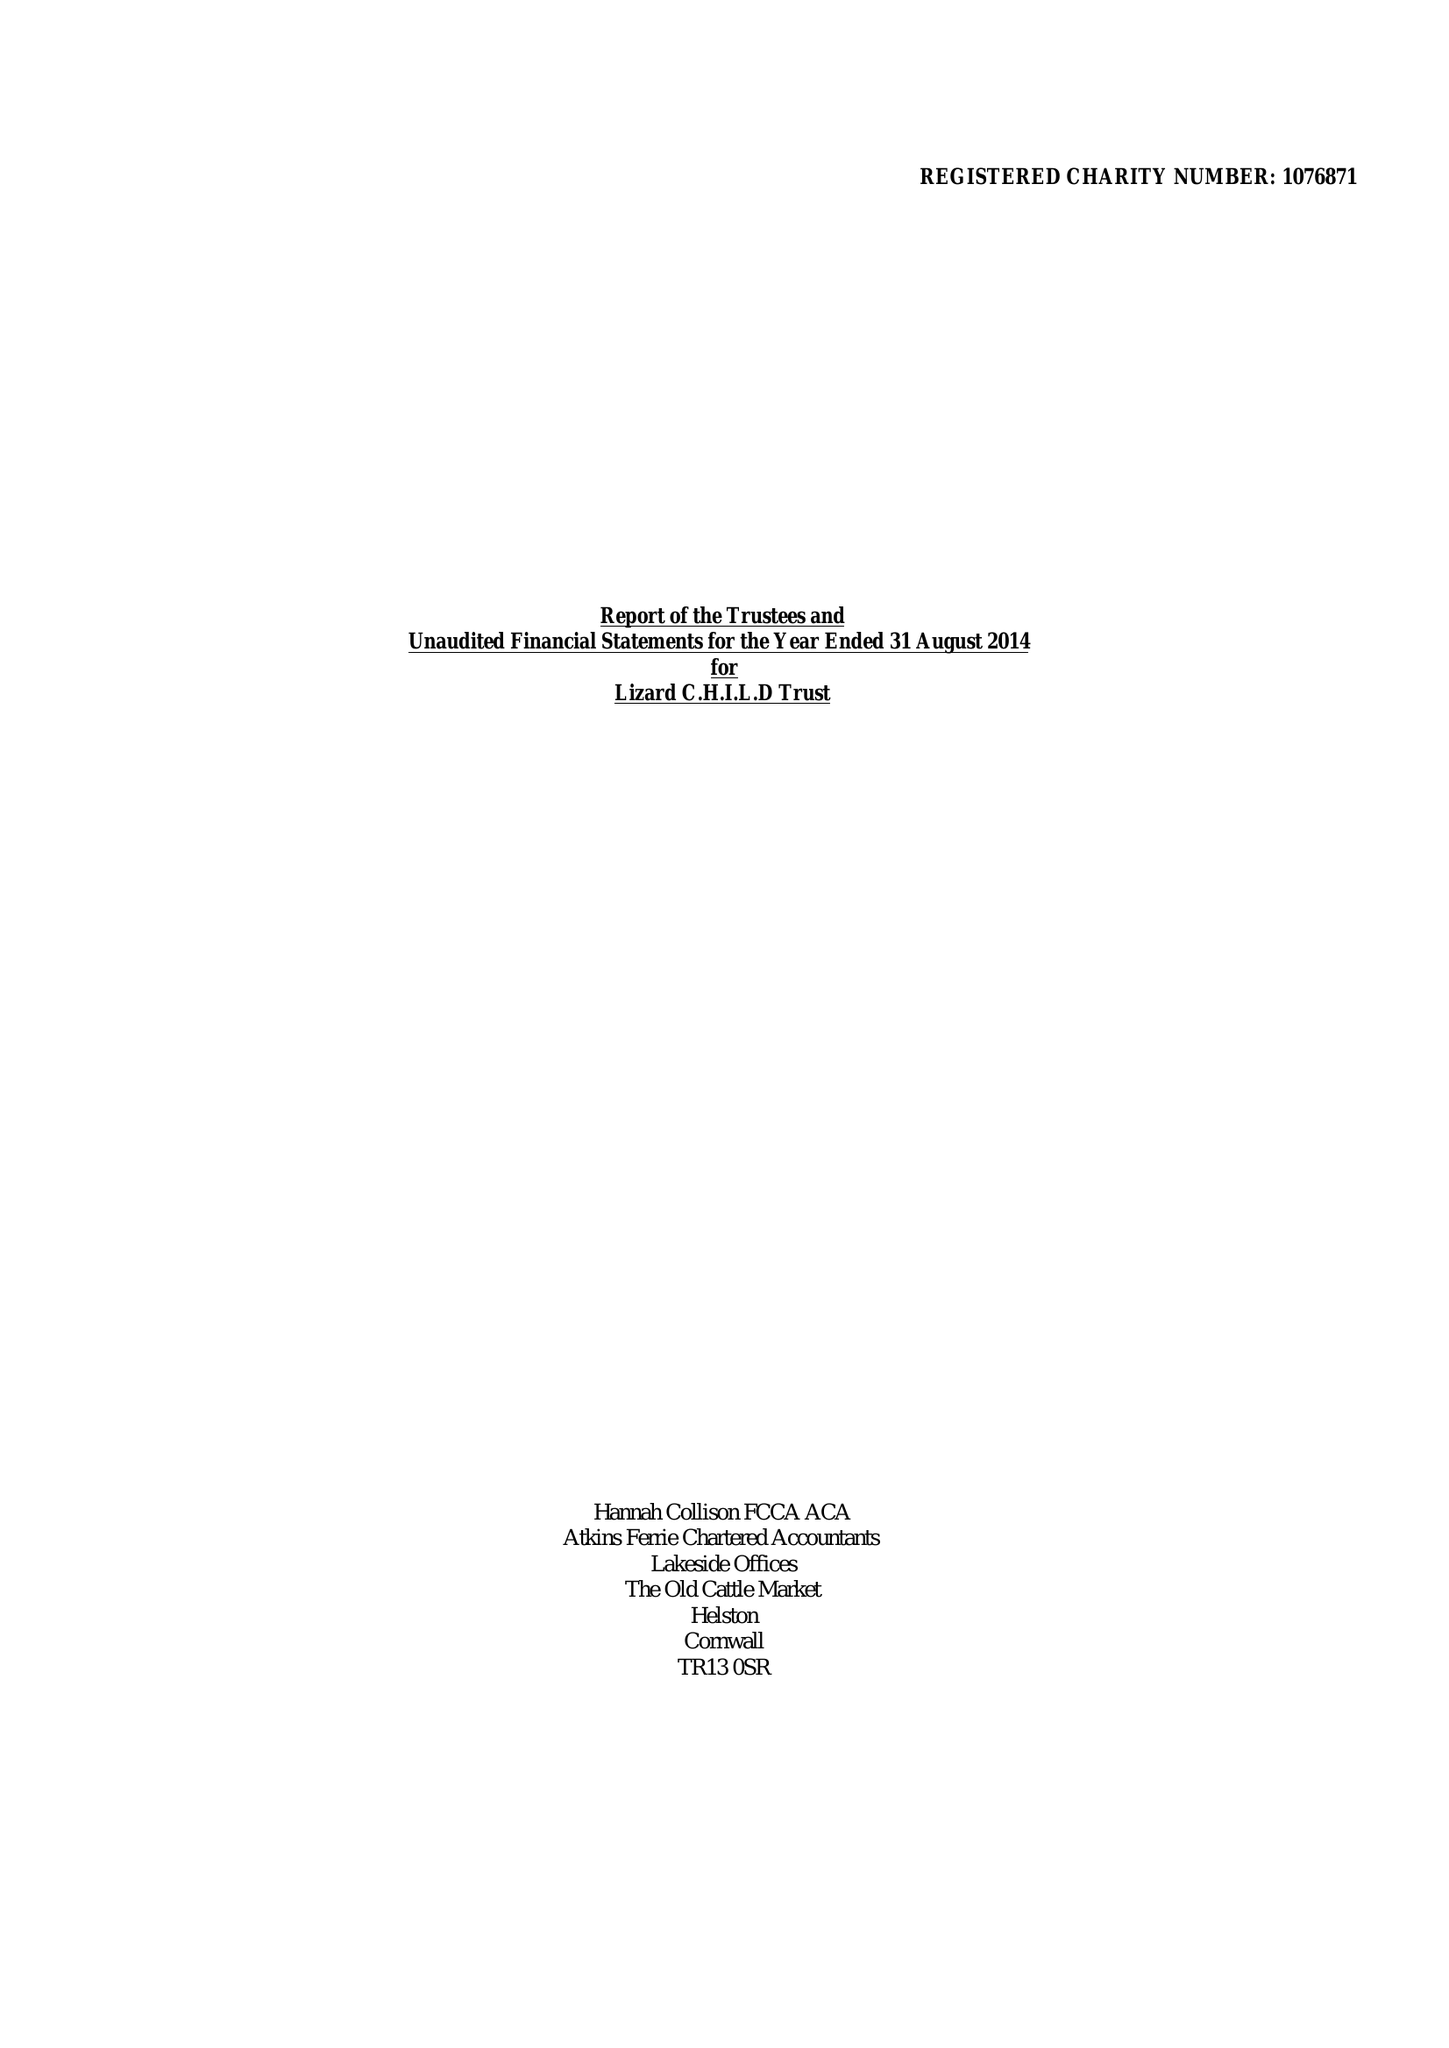What is the value for the address__postcode?
Answer the question using a single word or phrase. TR13 8AR 